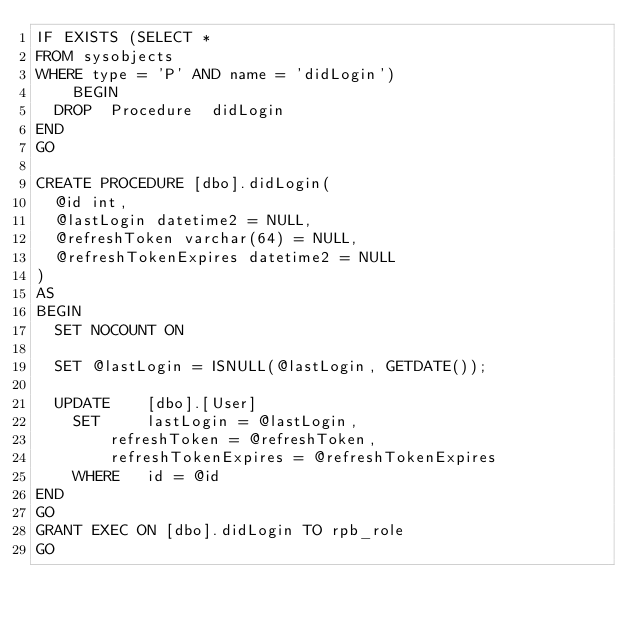<code> <loc_0><loc_0><loc_500><loc_500><_SQL_>IF EXISTS (SELECT *
FROM sysobjects
WHERE type = 'P' AND name = 'didLogin')
	BEGIN
  DROP  Procedure  didLogin
END
GO

CREATE PROCEDURE [dbo].didLogin(
  @id int,
  @lastLogin datetime2 = NULL,
  @refreshToken varchar(64) = NULL,
  @refreshTokenExpires datetime2 = NULL
)
AS
BEGIN
  SET NOCOUNT ON

  SET @lastLogin = ISNULL(@lastLogin, GETDATE());

  UPDATE	[dbo].[User]
    SET		lastLogin = @lastLogin,
        refreshToken = @refreshToken,
        refreshTokenExpires = @refreshTokenExpires
    WHERE	id = @id
END
GO
GRANT EXEC ON [dbo].didLogin TO rpb_role
GO</code> 